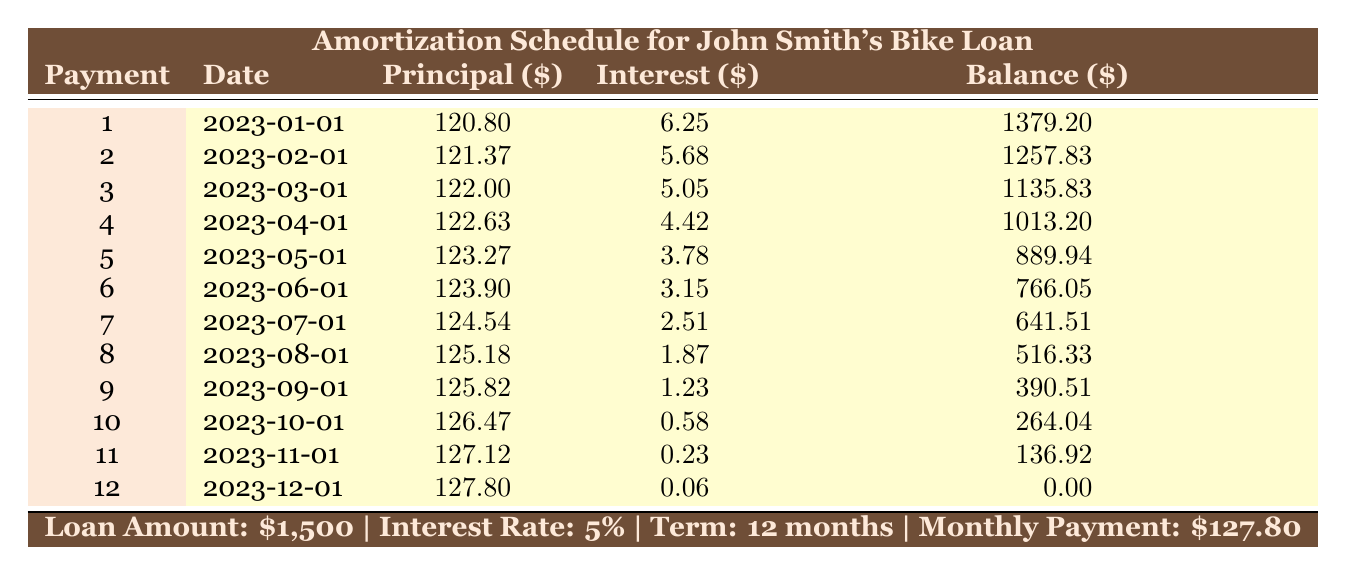What is the total amount of interest paid over the course of the loan? To find the total interest paid, we need to sum the interest payments from all 12 months. The interest payments are: 6.25 + 5.68 + 5.05 + 4.42 + 3.78 + 3.15 + 2.51 + 1.87 + 1.23 + 0.58 + 0.23 + 0.06 = 34.83.
Answer: 34.83 What was the principal repayment in the third month? In the third month, the principal repayment is directly listed in the table. Looking at the entry for payment number 3, the principal payment is 122.00.
Answer: 122.00 Is the remaining balance after the fifth payment lower than the balance after the fourth payment? To answer this, we compare the remaining balances after the fourth payment (1013.20) and the fifth payment (889.94). Since 889.94 is less than 1013.20, the statement is true.
Answer: Yes What was the interest payment in the final month? The interest payment for the twelfth month is listed in the table as 0.06.
Answer: 0.06 Which payment had the highest principal payment, and what was the amount? The table lists principal payments for each month, with the highest payment being 127.80 in the twelfth month.
Answer: 127.80 What is the average monthly principal payment over the entire loan period? The sum of all principal payments is calculated as follows: 120.80 + 121.37 + 122.00 + 122.63 + 123.27 + 123.90 + 124.54 + 125.18 + 125.82 + 126.47 + 127.12 + 127.80 = 1,493.90. To find the average, divide the total by the number of months: 1,493.90 / 12 = approximately 124.49.
Answer: 124.49 Did the interest payment ever drop below 1 dollar? From the table, the lowest interest payment is 0.06 in the twelfth month, which confirms that it dropped below 1 dollar.
Answer: Yes How much principal was paid off in the first half of the loan term (months 1 to 6)? The total principal paid in the first six months can be calculated by adding the principal payments: 120.80 + 121.37 + 122.00 + 122.63 + 123.27 + 123.90 = 733.97.
Answer: 733.97 At what payment number did the interest payment fall below 3 dollars for the first time? By reviewing the interest payments, it is evident that the first month where the interest payment fell below 3 dollars was the sixth month (3.15), so the seventh payment was the payment number in which this occurred.
Answer: 7 